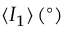Convert formula to latex. <formula><loc_0><loc_0><loc_500><loc_500>\langle I _ { 1 } \rangle \, ( ^ { \circ } )</formula> 